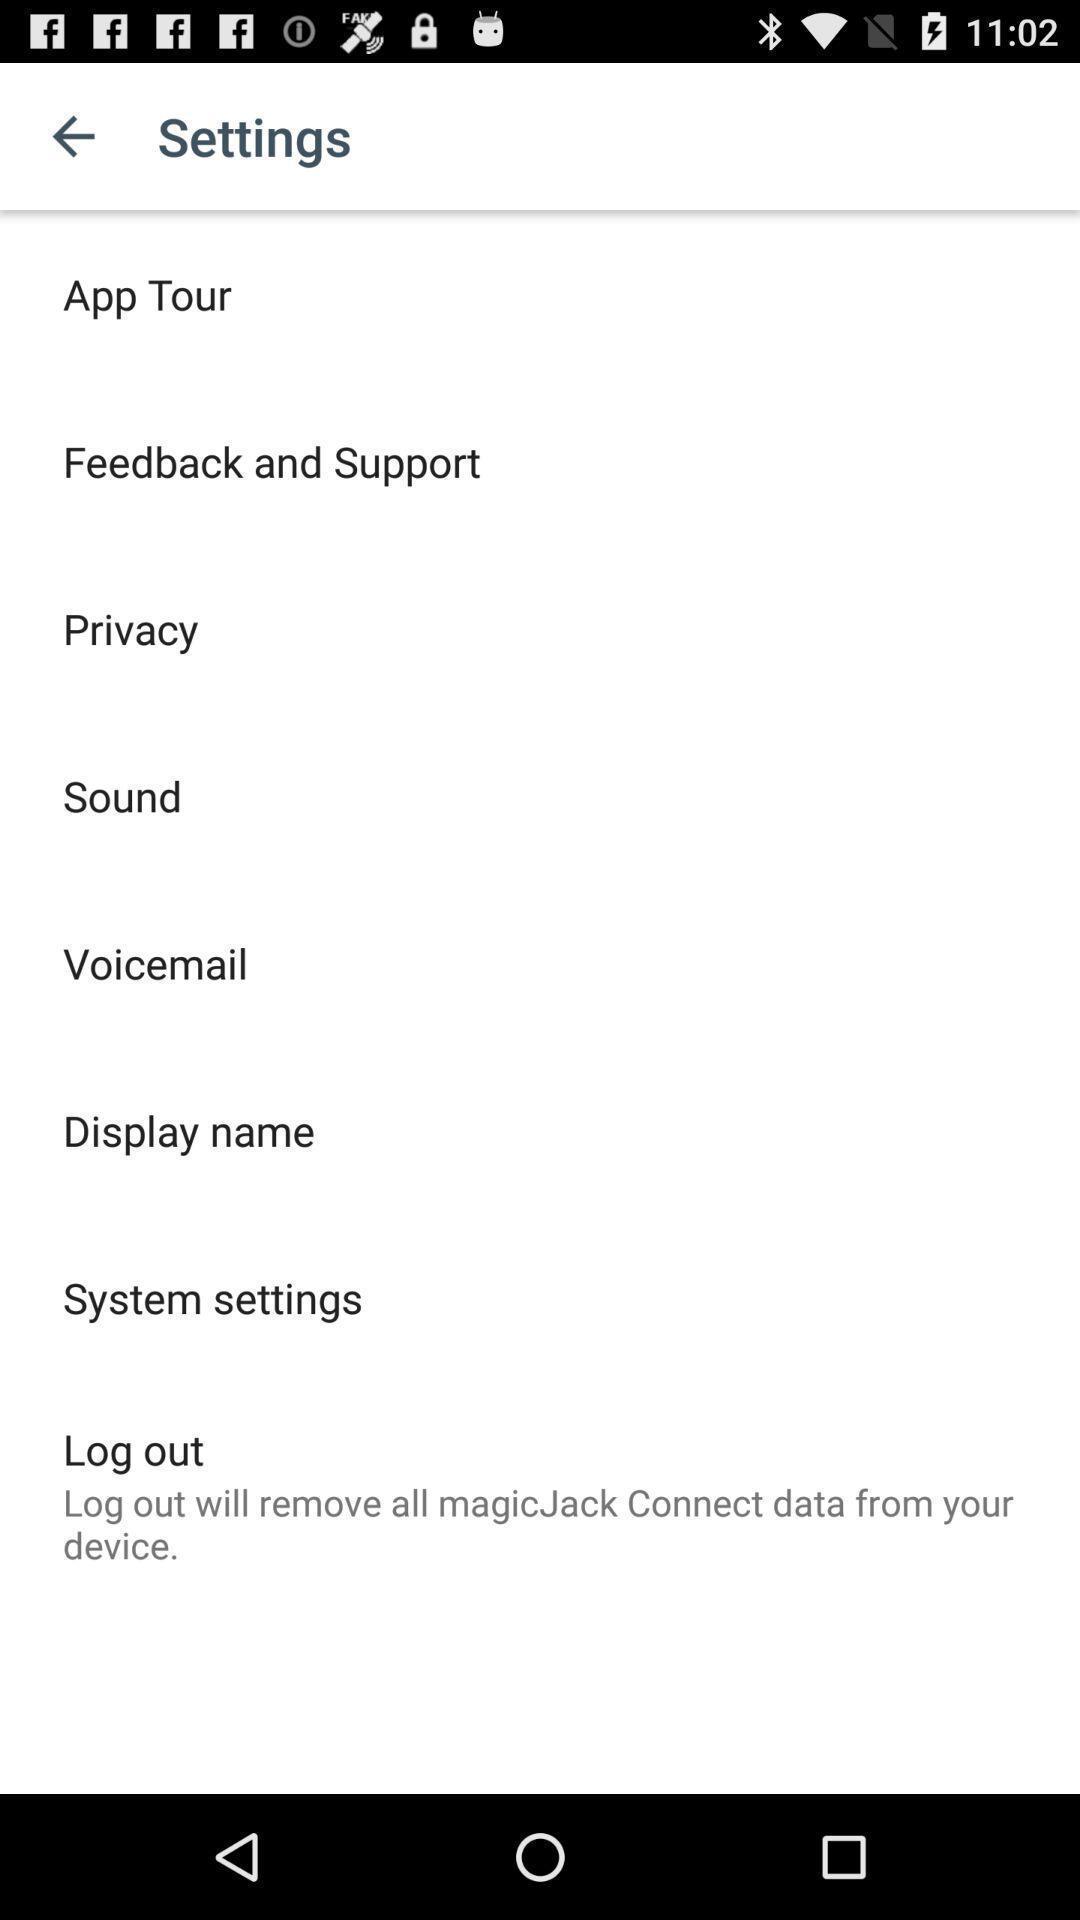What is the overall content of this screenshot? Screen displaying multiple options in settings page. 